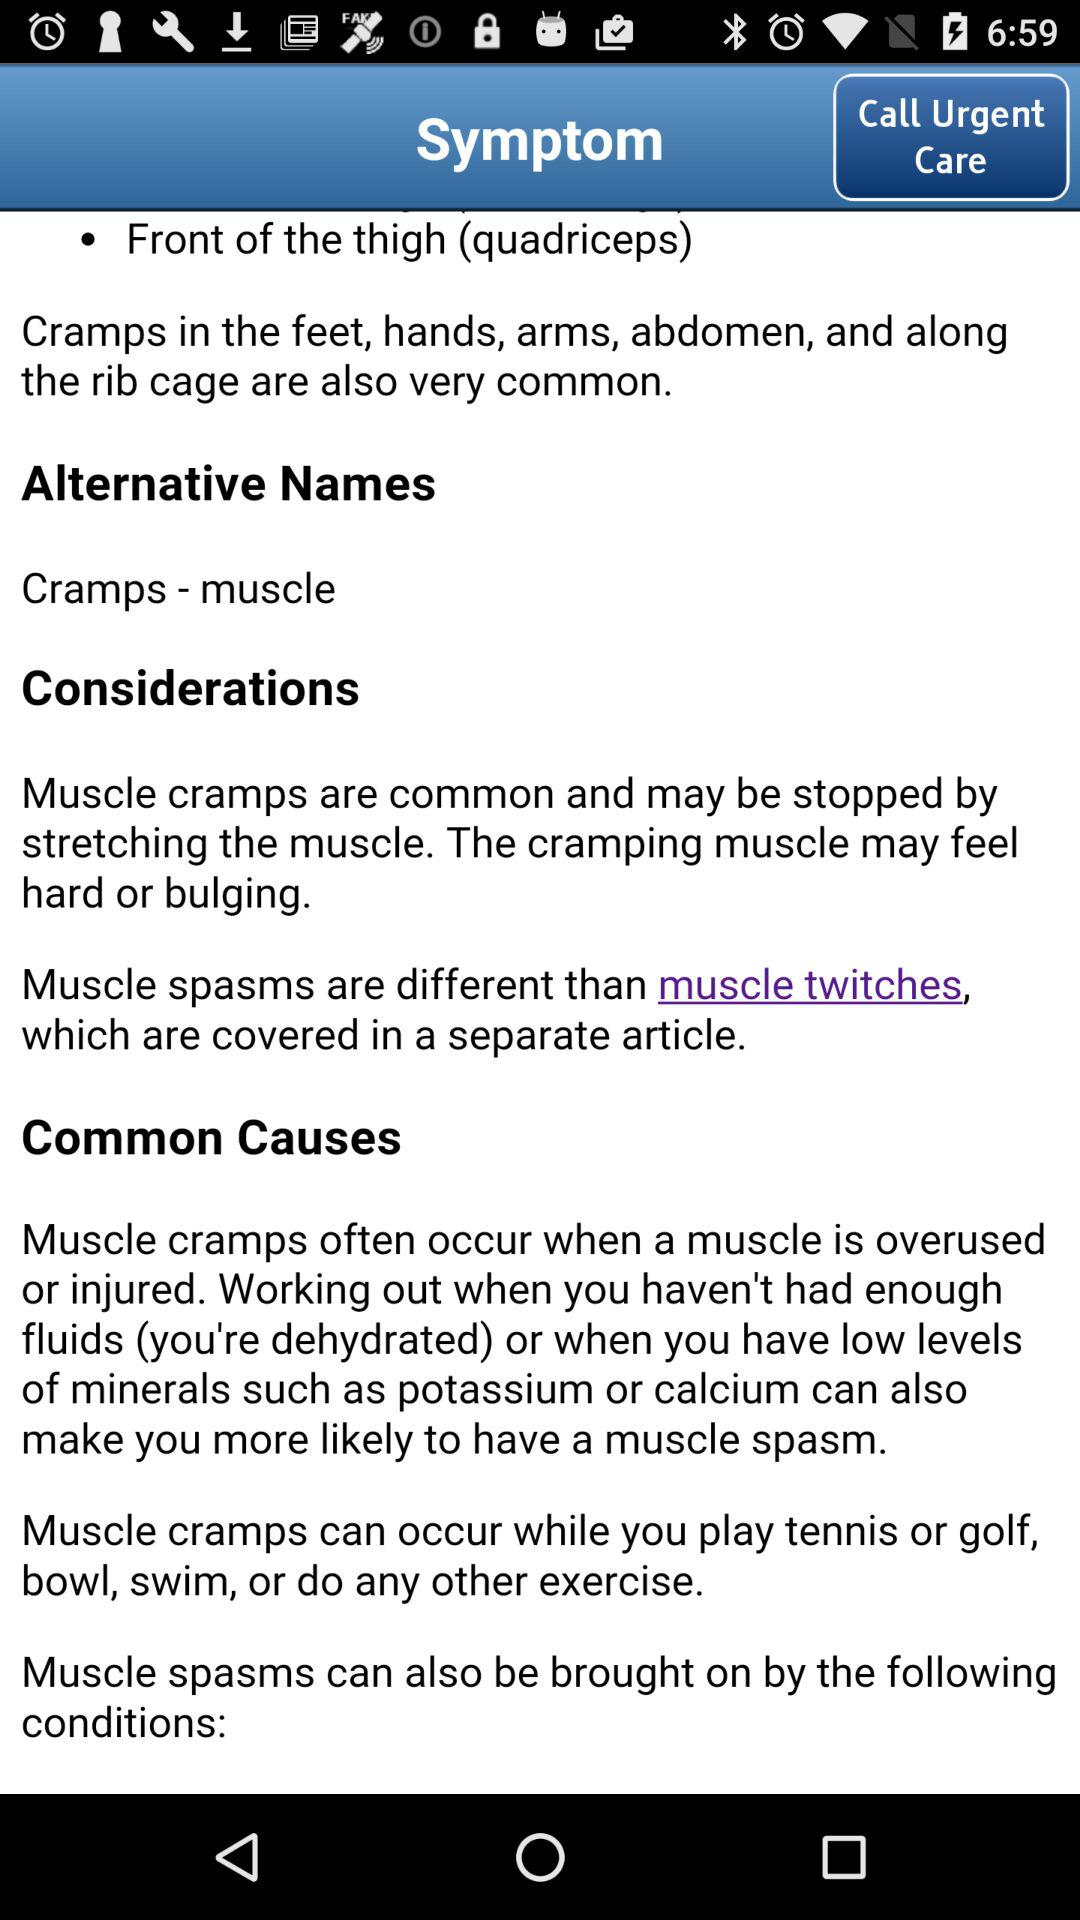In which part of the body are cramps very common? Cramps in the feet, hands, arms, abdomen and rib cage are very common. 